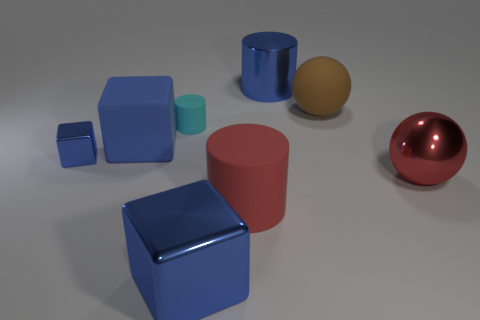What materials appear to be represented in this image? The objects in the image seem to have surfaces that resemble various materials. The shiny red and blue objects look like they could be a glossy plastic or polished metal, the pale object on the right appears to have a matte texture like clay or unglazed ceramic, and the pink and small blue objects have a flat color finish that suggests a matte plastic. 